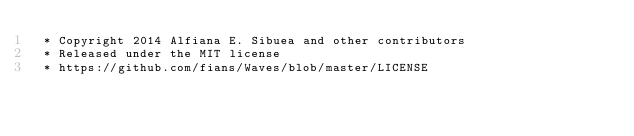<code> <loc_0><loc_0><loc_500><loc_500><_CSS_> * Copyright 2014 Alfiana E. Sibuea and other contributors
 * Released under the MIT license
 * https://github.com/fians/Waves/blob/master/LICENSE</code> 